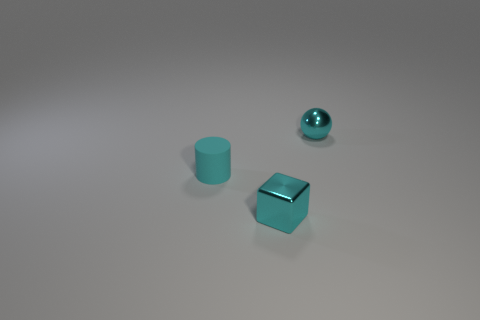Is the cyan sphere made of the same material as the small cylinder?
Your answer should be very brief. No. There is a shiny thing in front of the cyan metal thing that is right of the tiny block; what is its color?
Offer a very short reply. Cyan. There is a sphere that is the same material as the cyan cube; what size is it?
Your response must be concise. Small. How many objects are either tiny cyan metallic things in front of the cyan sphere or things that are in front of the matte object?
Your answer should be compact. 1. What number of small cyan things are in front of the shiny thing that is on the right side of the block?
Provide a succinct answer. 2. Does the cyan metal thing on the left side of the small cyan shiny ball have the same shape as the small shiny thing behind the tiny cyan cylinder?
Offer a very short reply. No. There is a metal thing that is the same color as the ball; what shape is it?
Offer a very short reply. Cube. Are there any cyan blocks that have the same material as the small cylinder?
Make the answer very short. No. What number of matte objects are tiny cyan cylinders or cyan objects?
Ensure brevity in your answer.  1. The metallic thing to the right of the small cyan metal object that is in front of the cyan metallic sphere is what shape?
Give a very brief answer. Sphere. 